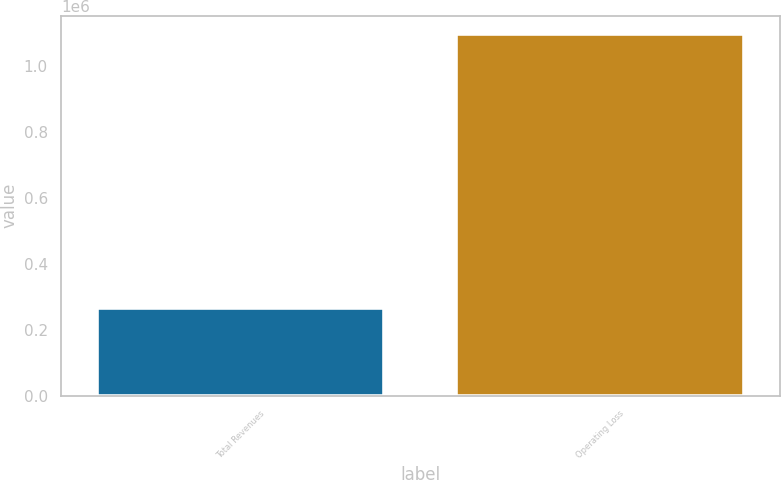Convert chart. <chart><loc_0><loc_0><loc_500><loc_500><bar_chart><fcel>Total Revenues<fcel>Operating Loss<nl><fcel>264900<fcel>1.09768e+06<nl></chart> 